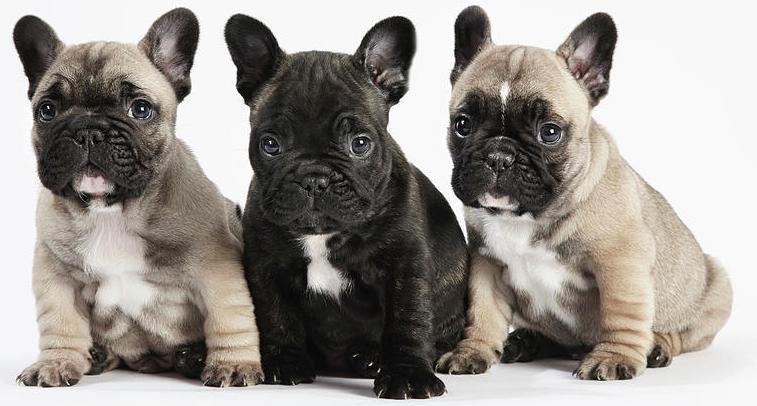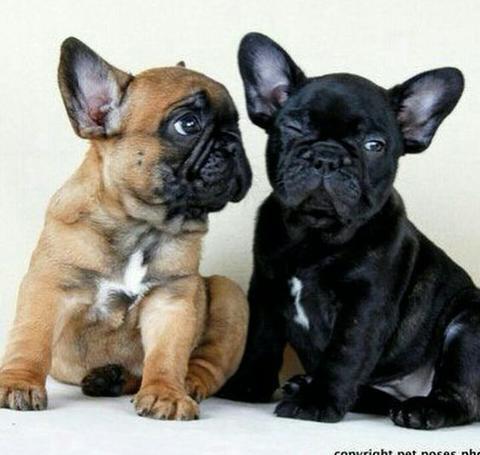The first image is the image on the left, the second image is the image on the right. Evaluate the accuracy of this statement regarding the images: "One dog has its mouth open and another dog has its mouth closed, and one of them is wearing a tie.". Is it true? Answer yes or no. No. The first image is the image on the left, the second image is the image on the right. For the images displayed, is the sentence "An image shows one dog, which is wearing something made of printed fabric around its neck." factually correct? Answer yes or no. No. 